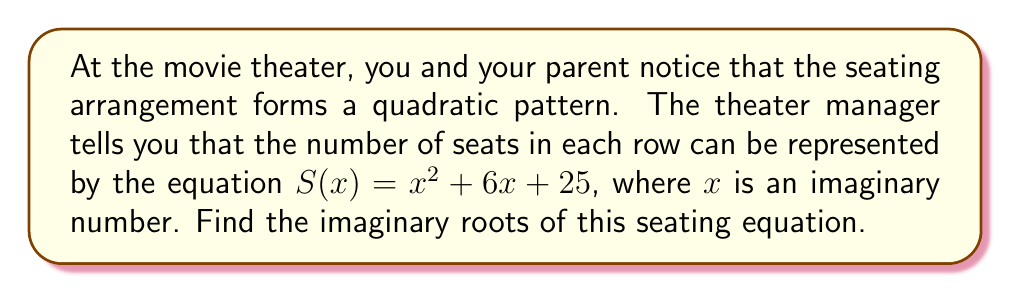Show me your answer to this math problem. Let's solve this step-by-step:

1) The equation is in the form $ax^2 + bx + c = 0$, where:
   $a = 1$
   $b = 6$
   $c = 25$

2) To find the roots, we use the quadratic formula: 
   $$x = \frac{-b \pm \sqrt{b^2 - 4ac}}{2a}$$

3) Substituting our values:
   $$x = \frac{-6 \pm \sqrt{6^2 - 4(1)(25)}}{2(1)}$$

4) Simplify under the square root:
   $$x = \frac{-6 \pm \sqrt{36 - 100}}{2}$$
   $$x = \frac{-6 \pm \sqrt{-64}}{2}$$

5) Simplify $\sqrt{-64}$:
   $$\sqrt{-64} = 8i$$

6) Therefore, our equation becomes:
   $$x = \frac{-6 \pm 8i}{2}$$

7) Simplify:
   $$x = -3 \pm 4i$$

8) So, the two roots are:
   $x_1 = -3 + 4i$ and $x_2 = -3 - 4i$
Answer: $-3 + 4i$ and $-3 - 4i$ 